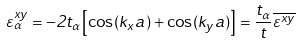<formula> <loc_0><loc_0><loc_500><loc_500>\varepsilon ^ { x y } _ { \alpha } = - 2 t _ { \alpha } \left [ \cos ( k _ { x } a ) + \cos ( k _ { y } a ) \right ] = \frac { t _ { \alpha } } { t } \overline { \varepsilon ^ { x y } }</formula> 